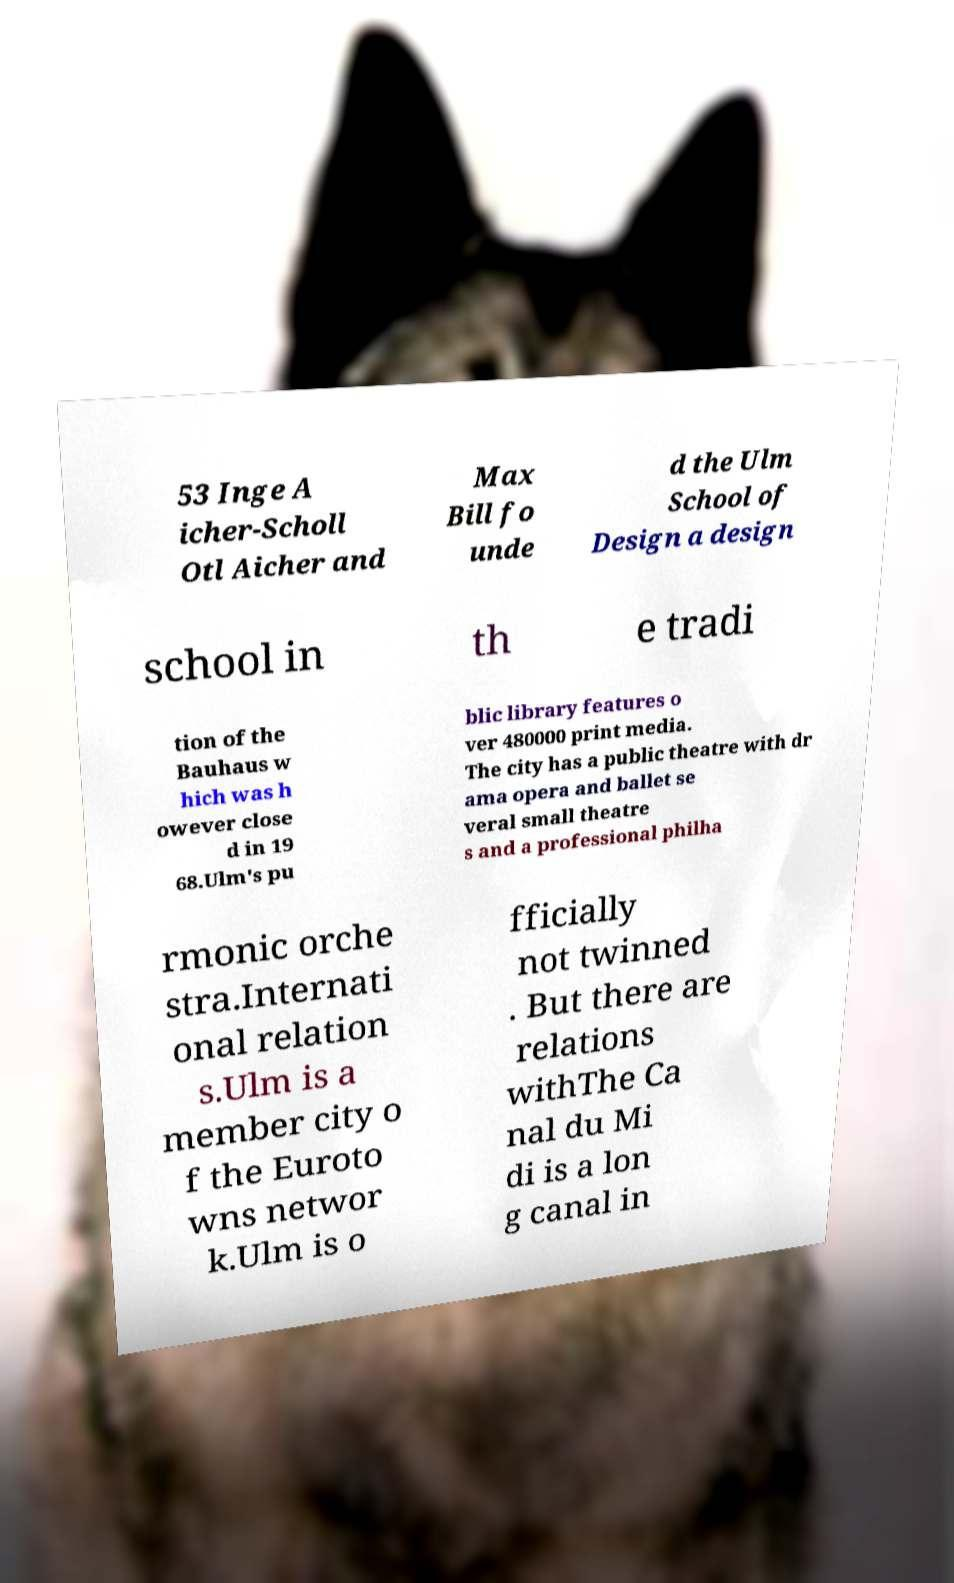I need the written content from this picture converted into text. Can you do that? 53 Inge A icher-Scholl Otl Aicher and Max Bill fo unde d the Ulm School of Design a design school in th e tradi tion of the Bauhaus w hich was h owever close d in 19 68.Ulm's pu blic library features o ver 480000 print media. The city has a public theatre with dr ama opera and ballet se veral small theatre s and a professional philha rmonic orche stra.Internati onal relation s.Ulm is a member city o f the Euroto wns networ k.Ulm is o fficially not twinned . But there are relations withThe Ca nal du Mi di is a lon g canal in 